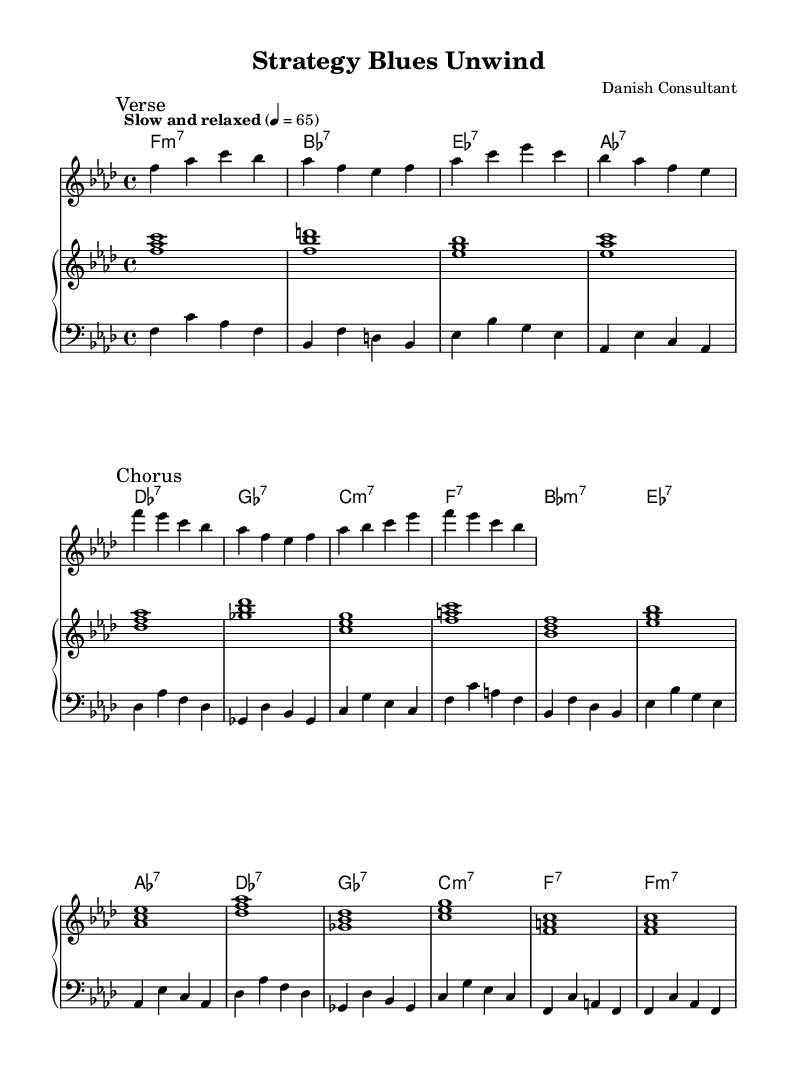What is the key signature of this music? The key signature is indicated at the beginning of the sheet music. It shows 4 flats, which correspond to the key of F minor.
Answer: F minor What is the time signature of this piece? The time signature can be found at the beginning of the score where the beats are indicated as 4 over 4, meaning there are four beats in a measure.
Answer: 4/4 What is the tempo marking for this composition? The tempo marking is noted in the score, stating "Slow and relaxed" with a metronome mark of 4 equals 65 beats per minute, indicating the piece should be played at a slow pace.
Answer: Slow and relaxed How many measures are in the verse section? By examining the melody section, we can count a total of 4 measures that belong to the verse, which is marked specifically in the music.
Answer: 4 measures What is the overall form of the music piece? Analyzing the structure, the sheet notes a clear delineation between the verse and chorus sections, suggesting a typical AABA format commonly found in Rhythm and Blues music.
Answer: AABA Which chords are used in the chorus section? The chorus section of the music specifies four unique chords: B flat minor 7, E flat 7, A flat 7, and D flat 7, which can be identified in the chord names aligned with the melody notes.
Answer: B flat minor 7, E flat 7, A flat 7, D flat 7 What style does this music piece represent? The sheet music notes that it is a "Jazz-influenced R&B," a blend that typically features relaxed rhythms with bluesy harmonies and a jazz sensibility, as reflected in the chord progressions and melodic lines.
Answer: Jazz-influenced R&B 